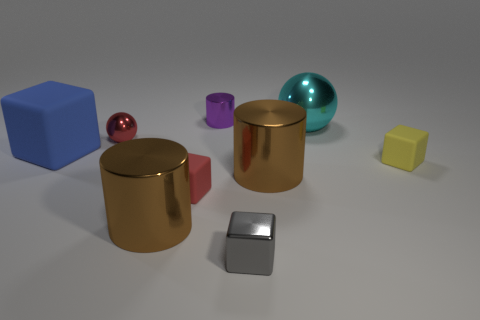Is the size of the yellow block the same as the red block?
Offer a very short reply. Yes. Is the sphere that is right of the tiny metallic sphere made of the same material as the red block?
Offer a terse response. No. There is a brown metallic cylinder that is behind the large brown thing left of the small metal block; how many large brown metallic things are in front of it?
Offer a very short reply. 1. There is a small rubber object that is left of the cyan metallic thing; is it the same shape as the tiny gray thing?
Keep it short and to the point. Yes. What number of things are either large blue shiny blocks or tiny cubes on the right side of the shiny block?
Offer a very short reply. 1. Are there more shiny spheres left of the purple object than yellow matte spheres?
Provide a succinct answer. Yes. Are there an equal number of matte cubes that are in front of the small gray object and small cubes that are to the right of the big blue matte cube?
Offer a terse response. No. There is a small metal object that is in front of the blue object; is there a gray shiny cube right of it?
Your answer should be compact. No. What is the shape of the cyan object?
Offer a terse response. Sphere. What is the size of the red thing in front of the matte object behind the yellow rubber cube?
Your response must be concise. Small. 